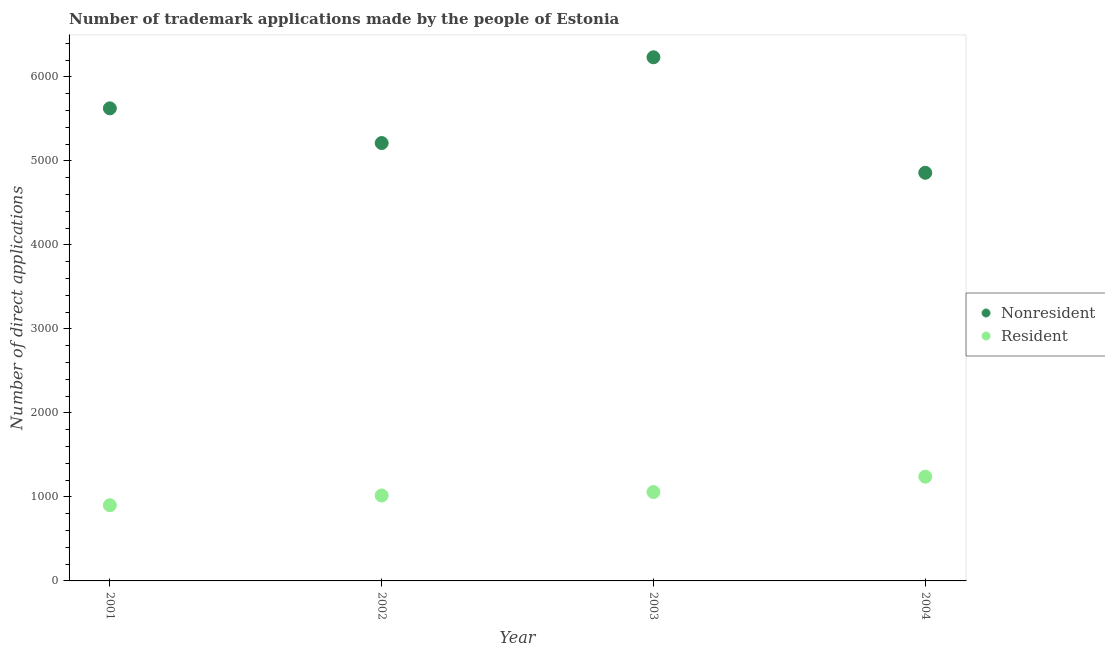How many different coloured dotlines are there?
Ensure brevity in your answer.  2. Is the number of dotlines equal to the number of legend labels?
Your answer should be compact. Yes. What is the number of trademark applications made by non residents in 2001?
Make the answer very short. 5626. Across all years, what is the maximum number of trademark applications made by residents?
Offer a terse response. 1241. Across all years, what is the minimum number of trademark applications made by residents?
Offer a very short reply. 901. In which year was the number of trademark applications made by non residents minimum?
Offer a terse response. 2004. What is the total number of trademark applications made by non residents in the graph?
Ensure brevity in your answer.  2.19e+04. What is the difference between the number of trademark applications made by non residents in 2002 and that in 2004?
Keep it short and to the point. 354. What is the difference between the number of trademark applications made by non residents in 2001 and the number of trademark applications made by residents in 2004?
Your response must be concise. 4385. What is the average number of trademark applications made by non residents per year?
Provide a succinct answer. 5483. In the year 2004, what is the difference between the number of trademark applications made by residents and number of trademark applications made by non residents?
Provide a short and direct response. -3618. What is the ratio of the number of trademark applications made by non residents in 2001 to that in 2002?
Provide a short and direct response. 1.08. What is the difference between the highest and the second highest number of trademark applications made by non residents?
Keep it short and to the point. 608. What is the difference between the highest and the lowest number of trademark applications made by residents?
Your response must be concise. 340. Is the number of trademark applications made by residents strictly greater than the number of trademark applications made by non residents over the years?
Provide a succinct answer. No. Is the number of trademark applications made by non residents strictly less than the number of trademark applications made by residents over the years?
Provide a short and direct response. No. Are the values on the major ticks of Y-axis written in scientific E-notation?
Your answer should be compact. No. How are the legend labels stacked?
Offer a very short reply. Vertical. What is the title of the graph?
Offer a very short reply. Number of trademark applications made by the people of Estonia. Does "Old" appear as one of the legend labels in the graph?
Keep it short and to the point. No. What is the label or title of the X-axis?
Offer a very short reply. Year. What is the label or title of the Y-axis?
Your answer should be very brief. Number of direct applications. What is the Number of direct applications of Nonresident in 2001?
Keep it short and to the point. 5626. What is the Number of direct applications in Resident in 2001?
Make the answer very short. 901. What is the Number of direct applications in Nonresident in 2002?
Keep it short and to the point. 5213. What is the Number of direct applications in Resident in 2002?
Offer a terse response. 1017. What is the Number of direct applications of Nonresident in 2003?
Give a very brief answer. 6234. What is the Number of direct applications in Resident in 2003?
Your response must be concise. 1058. What is the Number of direct applications of Nonresident in 2004?
Offer a terse response. 4859. What is the Number of direct applications of Resident in 2004?
Offer a terse response. 1241. Across all years, what is the maximum Number of direct applications in Nonresident?
Your response must be concise. 6234. Across all years, what is the maximum Number of direct applications of Resident?
Your answer should be compact. 1241. Across all years, what is the minimum Number of direct applications in Nonresident?
Ensure brevity in your answer.  4859. Across all years, what is the minimum Number of direct applications of Resident?
Your response must be concise. 901. What is the total Number of direct applications in Nonresident in the graph?
Offer a terse response. 2.19e+04. What is the total Number of direct applications in Resident in the graph?
Ensure brevity in your answer.  4217. What is the difference between the Number of direct applications in Nonresident in 2001 and that in 2002?
Give a very brief answer. 413. What is the difference between the Number of direct applications in Resident in 2001 and that in 2002?
Keep it short and to the point. -116. What is the difference between the Number of direct applications of Nonresident in 2001 and that in 2003?
Your answer should be compact. -608. What is the difference between the Number of direct applications in Resident in 2001 and that in 2003?
Your answer should be very brief. -157. What is the difference between the Number of direct applications of Nonresident in 2001 and that in 2004?
Your response must be concise. 767. What is the difference between the Number of direct applications in Resident in 2001 and that in 2004?
Your answer should be compact. -340. What is the difference between the Number of direct applications of Nonresident in 2002 and that in 2003?
Offer a terse response. -1021. What is the difference between the Number of direct applications in Resident in 2002 and that in 2003?
Provide a succinct answer. -41. What is the difference between the Number of direct applications of Nonresident in 2002 and that in 2004?
Offer a terse response. 354. What is the difference between the Number of direct applications in Resident in 2002 and that in 2004?
Keep it short and to the point. -224. What is the difference between the Number of direct applications of Nonresident in 2003 and that in 2004?
Offer a very short reply. 1375. What is the difference between the Number of direct applications of Resident in 2003 and that in 2004?
Offer a terse response. -183. What is the difference between the Number of direct applications of Nonresident in 2001 and the Number of direct applications of Resident in 2002?
Offer a very short reply. 4609. What is the difference between the Number of direct applications in Nonresident in 2001 and the Number of direct applications in Resident in 2003?
Provide a short and direct response. 4568. What is the difference between the Number of direct applications of Nonresident in 2001 and the Number of direct applications of Resident in 2004?
Your response must be concise. 4385. What is the difference between the Number of direct applications in Nonresident in 2002 and the Number of direct applications in Resident in 2003?
Keep it short and to the point. 4155. What is the difference between the Number of direct applications in Nonresident in 2002 and the Number of direct applications in Resident in 2004?
Provide a short and direct response. 3972. What is the difference between the Number of direct applications in Nonresident in 2003 and the Number of direct applications in Resident in 2004?
Give a very brief answer. 4993. What is the average Number of direct applications of Nonresident per year?
Your response must be concise. 5483. What is the average Number of direct applications of Resident per year?
Give a very brief answer. 1054.25. In the year 2001, what is the difference between the Number of direct applications of Nonresident and Number of direct applications of Resident?
Offer a very short reply. 4725. In the year 2002, what is the difference between the Number of direct applications in Nonresident and Number of direct applications in Resident?
Offer a very short reply. 4196. In the year 2003, what is the difference between the Number of direct applications in Nonresident and Number of direct applications in Resident?
Give a very brief answer. 5176. In the year 2004, what is the difference between the Number of direct applications in Nonresident and Number of direct applications in Resident?
Keep it short and to the point. 3618. What is the ratio of the Number of direct applications of Nonresident in 2001 to that in 2002?
Keep it short and to the point. 1.08. What is the ratio of the Number of direct applications of Resident in 2001 to that in 2002?
Your answer should be very brief. 0.89. What is the ratio of the Number of direct applications of Nonresident in 2001 to that in 2003?
Offer a very short reply. 0.9. What is the ratio of the Number of direct applications in Resident in 2001 to that in 2003?
Your response must be concise. 0.85. What is the ratio of the Number of direct applications in Nonresident in 2001 to that in 2004?
Offer a very short reply. 1.16. What is the ratio of the Number of direct applications in Resident in 2001 to that in 2004?
Give a very brief answer. 0.73. What is the ratio of the Number of direct applications of Nonresident in 2002 to that in 2003?
Keep it short and to the point. 0.84. What is the ratio of the Number of direct applications in Resident in 2002 to that in 2003?
Your response must be concise. 0.96. What is the ratio of the Number of direct applications of Nonresident in 2002 to that in 2004?
Your answer should be very brief. 1.07. What is the ratio of the Number of direct applications of Resident in 2002 to that in 2004?
Your response must be concise. 0.82. What is the ratio of the Number of direct applications of Nonresident in 2003 to that in 2004?
Offer a terse response. 1.28. What is the ratio of the Number of direct applications in Resident in 2003 to that in 2004?
Provide a short and direct response. 0.85. What is the difference between the highest and the second highest Number of direct applications in Nonresident?
Offer a very short reply. 608. What is the difference between the highest and the second highest Number of direct applications of Resident?
Ensure brevity in your answer.  183. What is the difference between the highest and the lowest Number of direct applications in Nonresident?
Make the answer very short. 1375. What is the difference between the highest and the lowest Number of direct applications in Resident?
Offer a terse response. 340. 